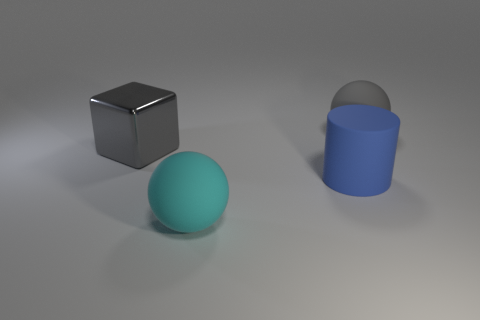What emotions do the colors and composition in the image evoke? The cool tones and clean lines give off a calm and orderly atmosphere, potentially evoking feelings of tranquility and simplicity. 